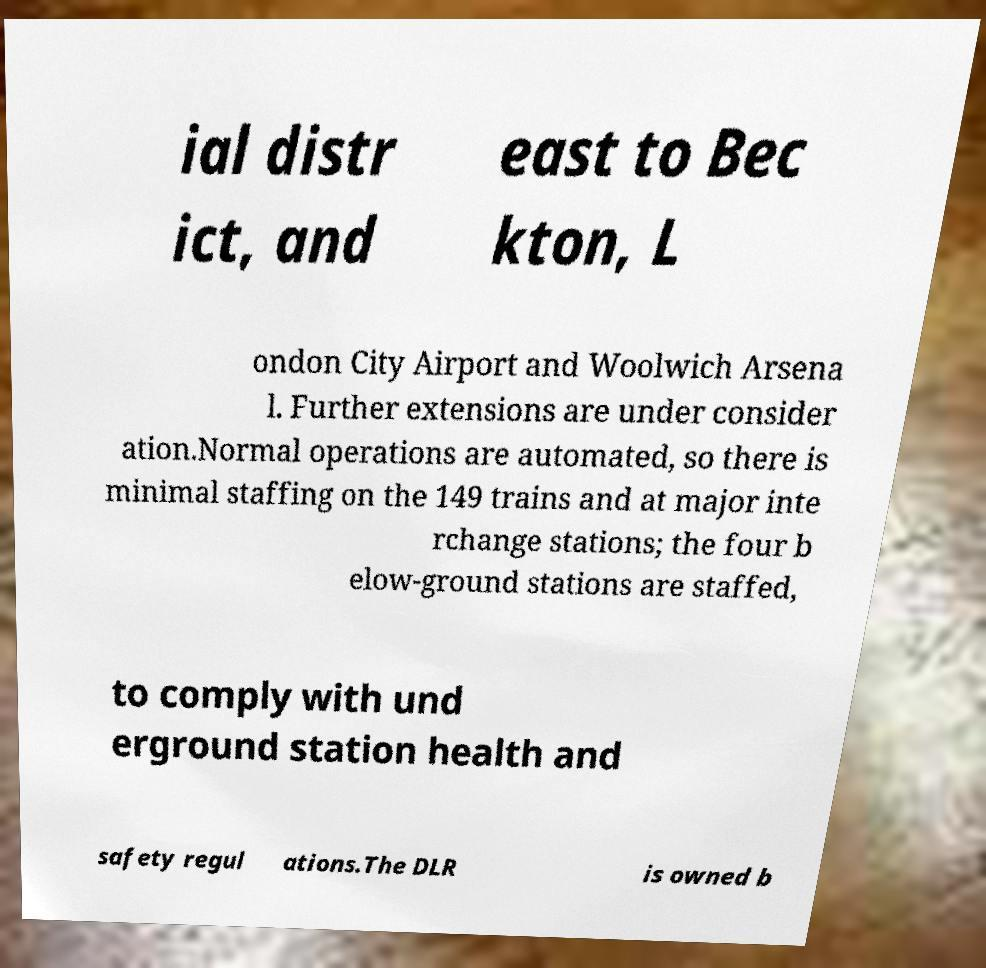Can you accurately transcribe the text from the provided image for me? ial distr ict, and east to Bec kton, L ondon City Airport and Woolwich Arsena l. Further extensions are under consider ation.Normal operations are automated, so there is minimal staffing on the 149 trains and at major inte rchange stations; the four b elow-ground stations are staffed, to comply with und erground station health and safety regul ations.The DLR is owned b 